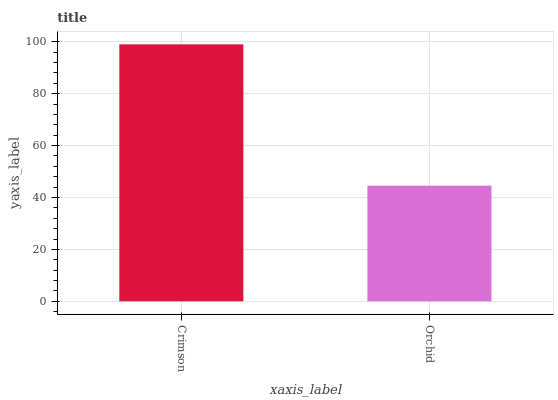Is Orchid the minimum?
Answer yes or no. Yes. Is Crimson the maximum?
Answer yes or no. Yes. Is Orchid the maximum?
Answer yes or no. No. Is Crimson greater than Orchid?
Answer yes or no. Yes. Is Orchid less than Crimson?
Answer yes or no. Yes. Is Orchid greater than Crimson?
Answer yes or no. No. Is Crimson less than Orchid?
Answer yes or no. No. Is Crimson the high median?
Answer yes or no. Yes. Is Orchid the low median?
Answer yes or no. Yes. Is Orchid the high median?
Answer yes or no. No. Is Crimson the low median?
Answer yes or no. No. 